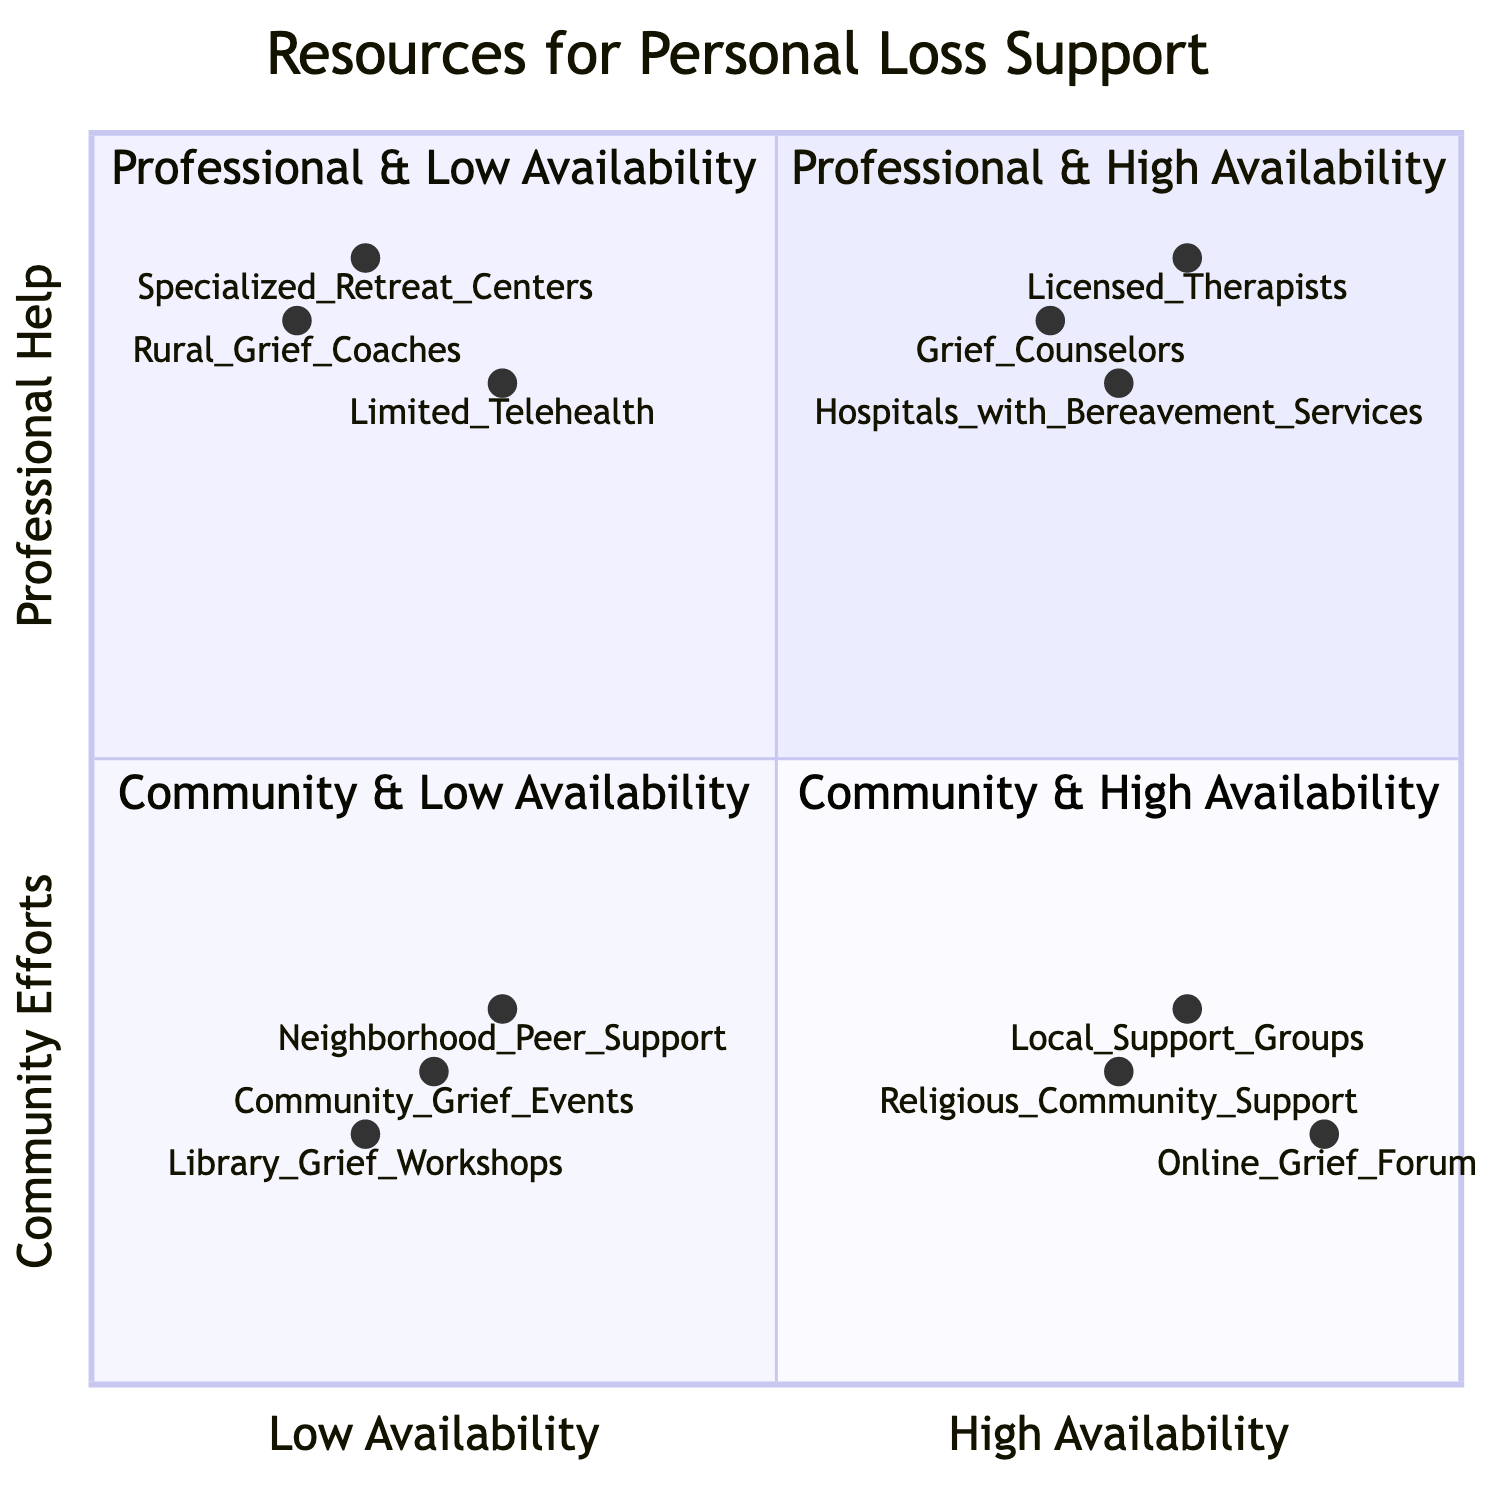What are three resources in the "High Availability & Professional Help" quadrant? The "High Availability & Professional Help" quadrant includes licensed therapists, grief counselors, and hospitals with bereavement services. These are explicitly listed under that quadrant in the data.
Answer: Licensed Therapists, Grief Counselors, Hospitals with Bereavement Services Which resource has the lowest availability and falls under "Community Efforts"? The resource with the lowest availability under "Community Efforts" is "Library Grief Workshops," as it is listed in the lowest availability category within the community efforts section.
Answer: Library Grief Workshops How many resources are in the "Low Availability & Community Efforts" quadrant? In the "Low Availability & Community Efforts" quadrant, there are three resources listed: neighborhood peer support circles, local library workshops on coping with loss, and periodic community grief events.
Answer: 3 Which resource is available both as "High Availability" and falls under "Professional Help"? The resource that is in the "High Availability & Professional Help" quadrant is "Licensed Therapists," as indicated by its position in the quadrant and its corresponding coordinates.
Answer: Licensed Therapists Which quadrant contains the most resources? The quadrant with the most resources based on the data provided is the "High Availability & Community Efforts" quadrant, which has three resources: support groups at local community centers, online grief forums, and church or religious community support.
Answer: High Availability & Community Efforts Which resource is the one with limited access in telehealth services? The resource listed under "Low Availability & Professional Help" that refers to limited access in telehealth services is "Limited Telehealth," as specifically categorized in the data provided.
Answer: Limited Telehealth What is the significance of the "High Availability & Community Efforts" quadrant in terms of support? The "High Availability & Community Efforts" quadrant signifies that many local and online support mechanisms are readily accessible to individuals seeking help, including support groups and online forums, which often promote peer support in managing grief.
Answer: High Availability & Community Efforts 